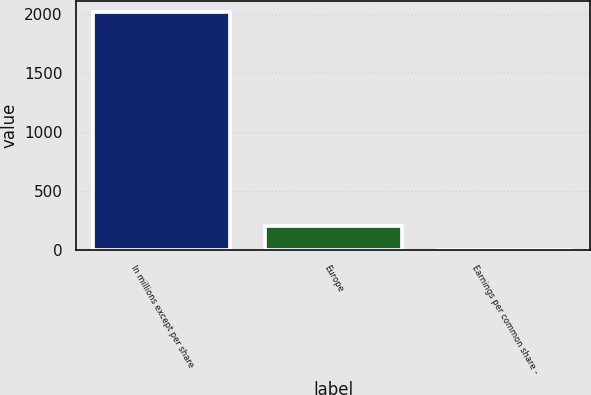Convert chart to OTSL. <chart><loc_0><loc_0><loc_500><loc_500><bar_chart><fcel>In millions except per share<fcel>Europe<fcel>Earnings per common share -<nl><fcel>2010<fcel>201.02<fcel>0.02<nl></chart> 